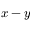Convert formula to latex. <formula><loc_0><loc_0><loc_500><loc_500>x - y</formula> 